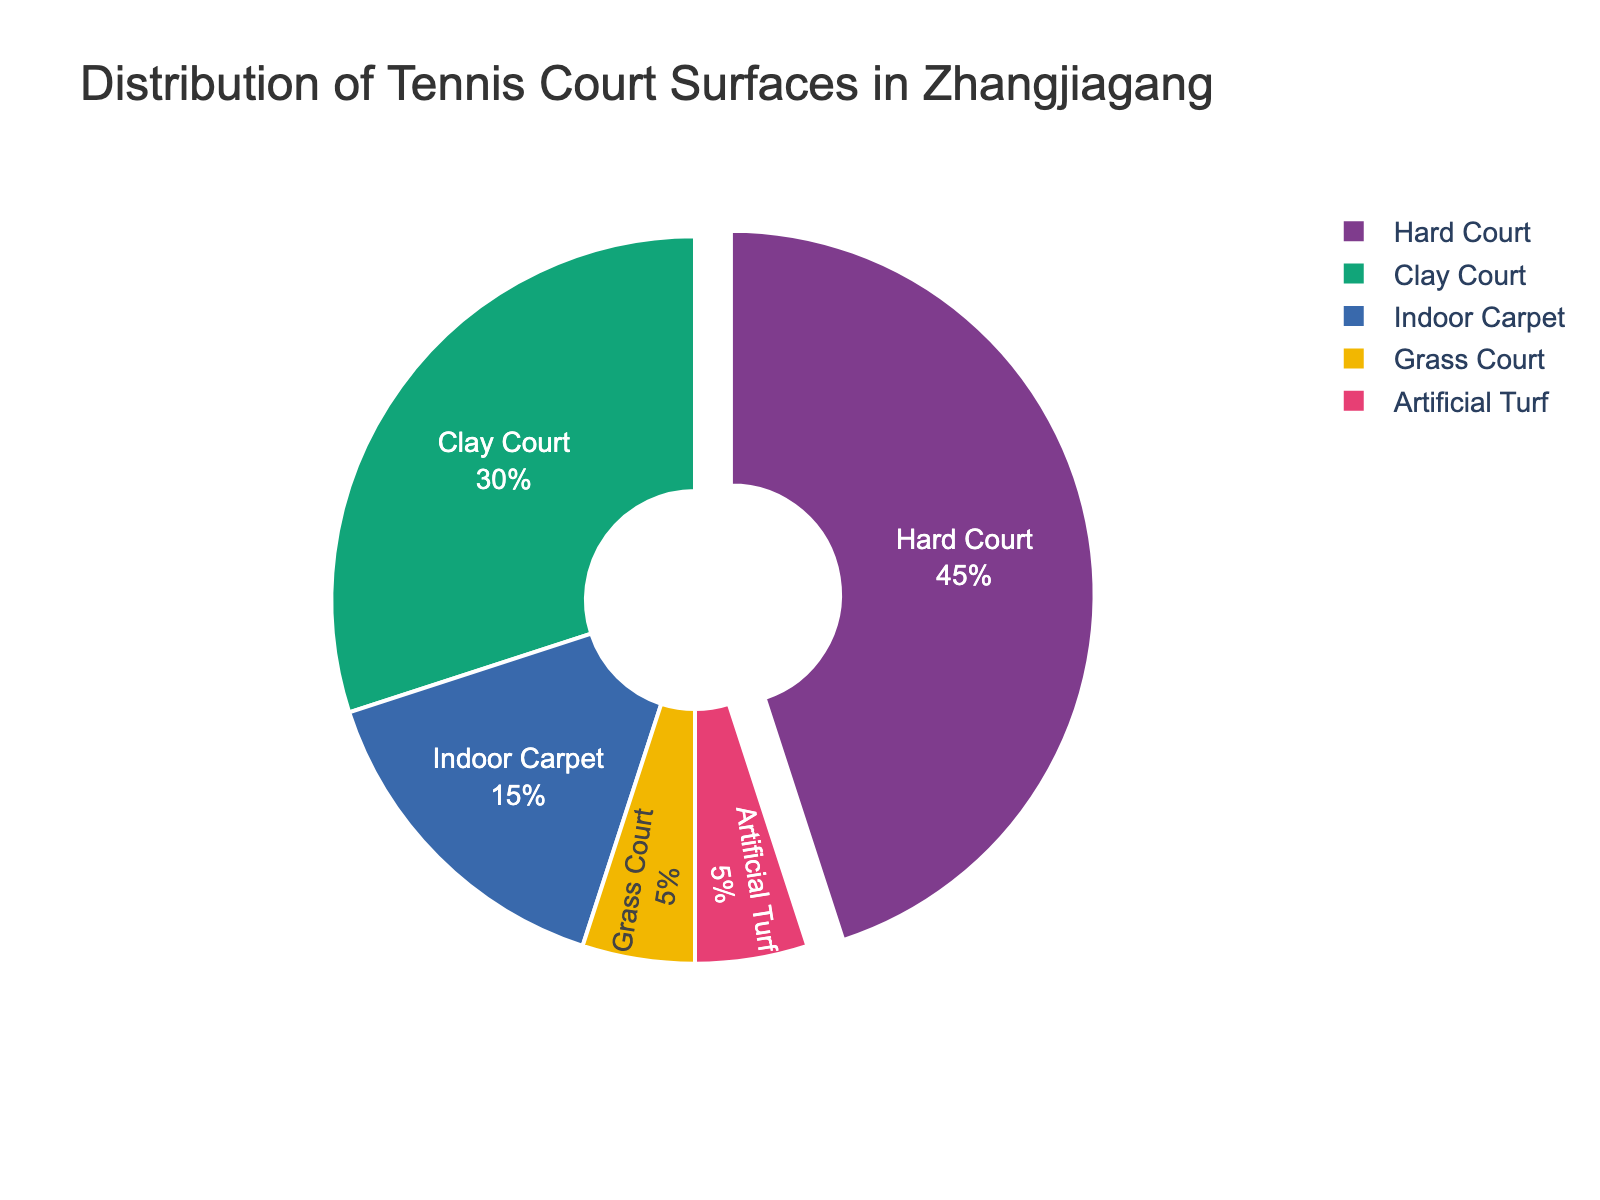What is the most common tennis court surface in Zhangjiagang? The figure shows a pie chart where each slice represents a surface type. The largest slice, indicated as accounting for 45%, corresponds to Hard Court.
Answer: Hard Court Which tennis court surfaces have the same percentage distribution? By examining the pie chart, we can see that Grass Court and Artificial Turf each account for 5% of the total distribution, making their percentages equal.
Answer: Grass Court and Artificial Turf What percentage of tennis courts are either Clay or Indoor Carpet surfaces? According to the chart, Clay Courts account for 30% and Indoor Carpet surfaces account for 15%. Adding these values gives 30% + 15% = 45%.
Answer: 45% How does the percentage of Hard Courts compare to the percentage of Indoor Carpet courts? The pie chart indicates that Hard Courts make up 45% and Indoor Carpet courts make up 15%. Comparing these values, Hard Courts have a higher percentage.
Answer: Higher What is the combined percentage for the least common and the most common tennis court surfaces? The least common surfaces are Grass Courts and Artificial Turf, each at 5%. The most common surface is Hard Court at 45%. Adding these, the combined percentage is 5% + 5% + 45% = 55%.
Answer: 55% Which surface type is represented in green? Upon examining the color scheme of the pie chart, Indoor Carpet is represented by the green slice which accounts for 15% of the surfaces.
Answer: Indoor Carpet If you exclude Hard Courts, what is the average percentage share of the remaining tennis court surfaces? Excluding the Hard Courts' 45%, the remaining surfaces are Clay Courts (30%), Grass Courts (5%), Indoor Carpet (15%), and Artificial Turf (5%). The average percentage share is calculated as (30 + 5 + 15 + 5) / 4 = 13.75%.
Answer: 13.75% What is the difference in percentage between Clay Courts and Grass Courts? The pie chart shows Clay Courts at 30% and Grass Courts at 5%. The difference between them is 30% - 5% = 25%.
Answer: 25% 